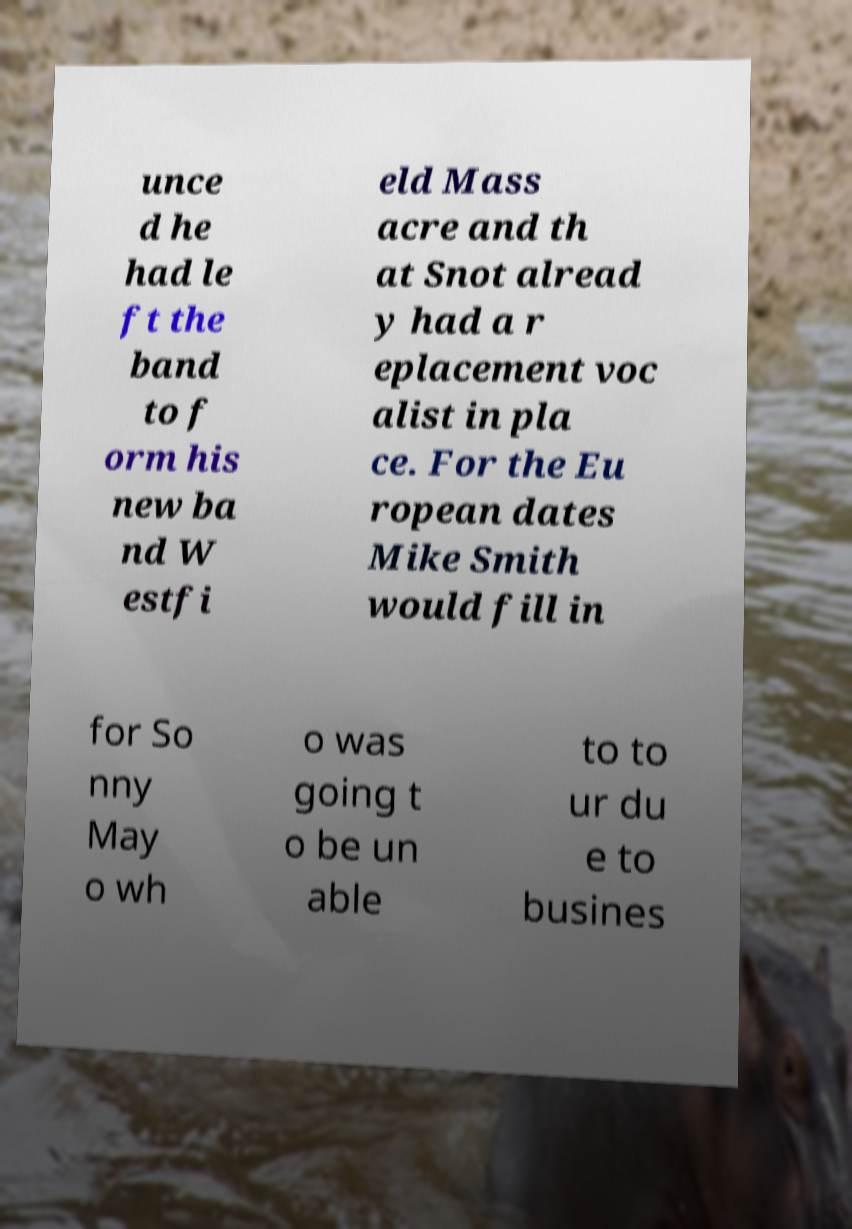Could you assist in decoding the text presented in this image and type it out clearly? unce d he had le ft the band to f orm his new ba nd W estfi eld Mass acre and th at Snot alread y had a r eplacement voc alist in pla ce. For the Eu ropean dates Mike Smith would fill in for So nny May o wh o was going t o be un able to to ur du e to busines 